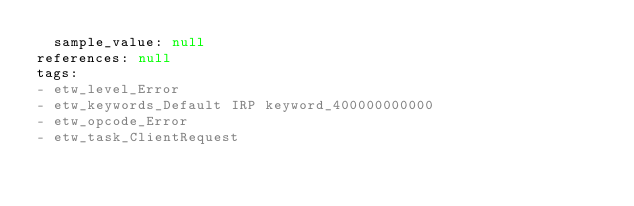Convert code to text. <code><loc_0><loc_0><loc_500><loc_500><_YAML_>  sample_value: null
references: null
tags:
- etw_level_Error
- etw_keywords_Default IRP keyword_400000000000
- etw_opcode_Error
- etw_task_ClientRequest
</code> 